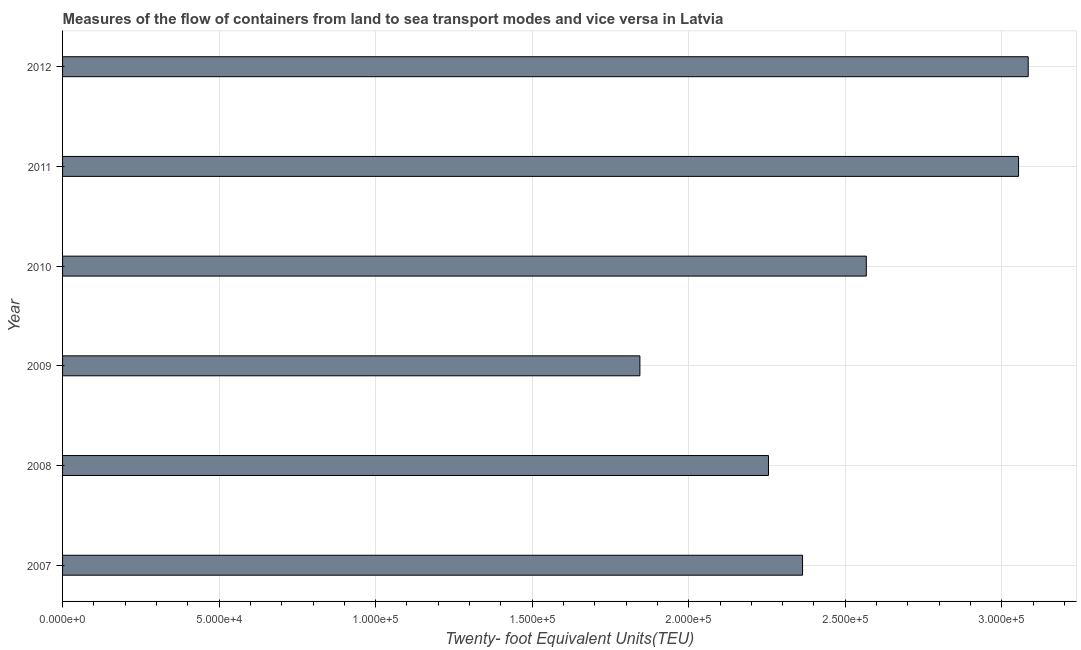Does the graph contain any zero values?
Offer a very short reply. No. Does the graph contain grids?
Keep it short and to the point. Yes. What is the title of the graph?
Keep it short and to the point. Measures of the flow of containers from land to sea transport modes and vice versa in Latvia. What is the label or title of the X-axis?
Provide a succinct answer. Twenty- foot Equivalent Units(TEU). What is the container port traffic in 2012?
Make the answer very short. 3.08e+05. Across all years, what is the maximum container port traffic?
Provide a succinct answer. 3.08e+05. Across all years, what is the minimum container port traffic?
Your answer should be compact. 1.84e+05. In which year was the container port traffic maximum?
Give a very brief answer. 2012. What is the sum of the container port traffic?
Offer a very short reply. 1.52e+06. What is the difference between the container port traffic in 2007 and 2008?
Keep it short and to the point. 1.09e+04. What is the average container port traffic per year?
Provide a succinct answer. 2.53e+05. What is the median container port traffic?
Your answer should be compact. 2.47e+05. In how many years, is the container port traffic greater than 310000 TEU?
Your answer should be compact. 0. Do a majority of the years between 2008 and 2009 (inclusive) have container port traffic greater than 270000 TEU?
Your answer should be compact. No. What is the ratio of the container port traffic in 2008 to that in 2009?
Your response must be concise. 1.22. Is the container port traffic in 2011 less than that in 2012?
Your answer should be compact. Yes. What is the difference between the highest and the second highest container port traffic?
Your answer should be compact. 3086.24. Is the sum of the container port traffic in 2010 and 2012 greater than the maximum container port traffic across all years?
Your answer should be very brief. Yes. What is the difference between the highest and the lowest container port traffic?
Keep it short and to the point. 1.24e+05. How many bars are there?
Your answer should be compact. 6. How many years are there in the graph?
Your answer should be compact. 6. What is the Twenty- foot Equivalent Units(TEU) of 2007?
Provide a short and direct response. 2.36e+05. What is the Twenty- foot Equivalent Units(TEU) in 2008?
Make the answer very short. 2.25e+05. What is the Twenty- foot Equivalent Units(TEU) in 2009?
Provide a short and direct response. 1.84e+05. What is the Twenty- foot Equivalent Units(TEU) of 2010?
Keep it short and to the point. 2.57e+05. What is the Twenty- foot Equivalent Units(TEU) of 2011?
Provide a succinct answer. 3.05e+05. What is the Twenty- foot Equivalent Units(TEU) of 2012?
Make the answer very short. 3.08e+05. What is the difference between the Twenty- foot Equivalent Units(TEU) in 2007 and 2008?
Your answer should be compact. 1.09e+04. What is the difference between the Twenty- foot Equivalent Units(TEU) in 2007 and 2009?
Give a very brief answer. 5.20e+04. What is the difference between the Twenty- foot Equivalent Units(TEU) in 2007 and 2010?
Keep it short and to the point. -2.04e+04. What is the difference between the Twenty- foot Equivalent Units(TEU) in 2007 and 2011?
Offer a terse response. -6.90e+04. What is the difference between the Twenty- foot Equivalent Units(TEU) in 2007 and 2012?
Keep it short and to the point. -7.21e+04. What is the difference between the Twenty- foot Equivalent Units(TEU) in 2008 and 2009?
Give a very brief answer. 4.11e+04. What is the difference between the Twenty- foot Equivalent Units(TEU) in 2008 and 2010?
Provide a short and direct response. -3.12e+04. What is the difference between the Twenty- foot Equivalent Units(TEU) in 2008 and 2011?
Your answer should be compact. -7.99e+04. What is the difference between the Twenty- foot Equivalent Units(TEU) in 2008 and 2012?
Your response must be concise. -8.30e+04. What is the difference between the Twenty- foot Equivalent Units(TEU) in 2009 and 2010?
Your response must be concise. -7.23e+04. What is the difference between the Twenty- foot Equivalent Units(TEU) in 2009 and 2011?
Your answer should be very brief. -1.21e+05. What is the difference between the Twenty- foot Equivalent Units(TEU) in 2009 and 2012?
Make the answer very short. -1.24e+05. What is the difference between the Twenty- foot Equivalent Units(TEU) in 2010 and 2011?
Provide a short and direct response. -4.86e+04. What is the difference between the Twenty- foot Equivalent Units(TEU) in 2010 and 2012?
Your response must be concise. -5.17e+04. What is the difference between the Twenty- foot Equivalent Units(TEU) in 2011 and 2012?
Provide a succinct answer. -3086.24. What is the ratio of the Twenty- foot Equivalent Units(TEU) in 2007 to that in 2008?
Provide a succinct answer. 1.05. What is the ratio of the Twenty- foot Equivalent Units(TEU) in 2007 to that in 2009?
Provide a short and direct response. 1.28. What is the ratio of the Twenty- foot Equivalent Units(TEU) in 2007 to that in 2010?
Your answer should be compact. 0.92. What is the ratio of the Twenty- foot Equivalent Units(TEU) in 2007 to that in 2011?
Your response must be concise. 0.77. What is the ratio of the Twenty- foot Equivalent Units(TEU) in 2007 to that in 2012?
Your answer should be very brief. 0.77. What is the ratio of the Twenty- foot Equivalent Units(TEU) in 2008 to that in 2009?
Make the answer very short. 1.22. What is the ratio of the Twenty- foot Equivalent Units(TEU) in 2008 to that in 2010?
Give a very brief answer. 0.88. What is the ratio of the Twenty- foot Equivalent Units(TEU) in 2008 to that in 2011?
Make the answer very short. 0.74. What is the ratio of the Twenty- foot Equivalent Units(TEU) in 2008 to that in 2012?
Make the answer very short. 0.73. What is the ratio of the Twenty- foot Equivalent Units(TEU) in 2009 to that in 2010?
Your answer should be very brief. 0.72. What is the ratio of the Twenty- foot Equivalent Units(TEU) in 2009 to that in 2011?
Provide a short and direct response. 0.6. What is the ratio of the Twenty- foot Equivalent Units(TEU) in 2009 to that in 2012?
Give a very brief answer. 0.6. What is the ratio of the Twenty- foot Equivalent Units(TEU) in 2010 to that in 2011?
Your answer should be very brief. 0.84. What is the ratio of the Twenty- foot Equivalent Units(TEU) in 2010 to that in 2012?
Give a very brief answer. 0.83. What is the ratio of the Twenty- foot Equivalent Units(TEU) in 2011 to that in 2012?
Your answer should be very brief. 0.99. 